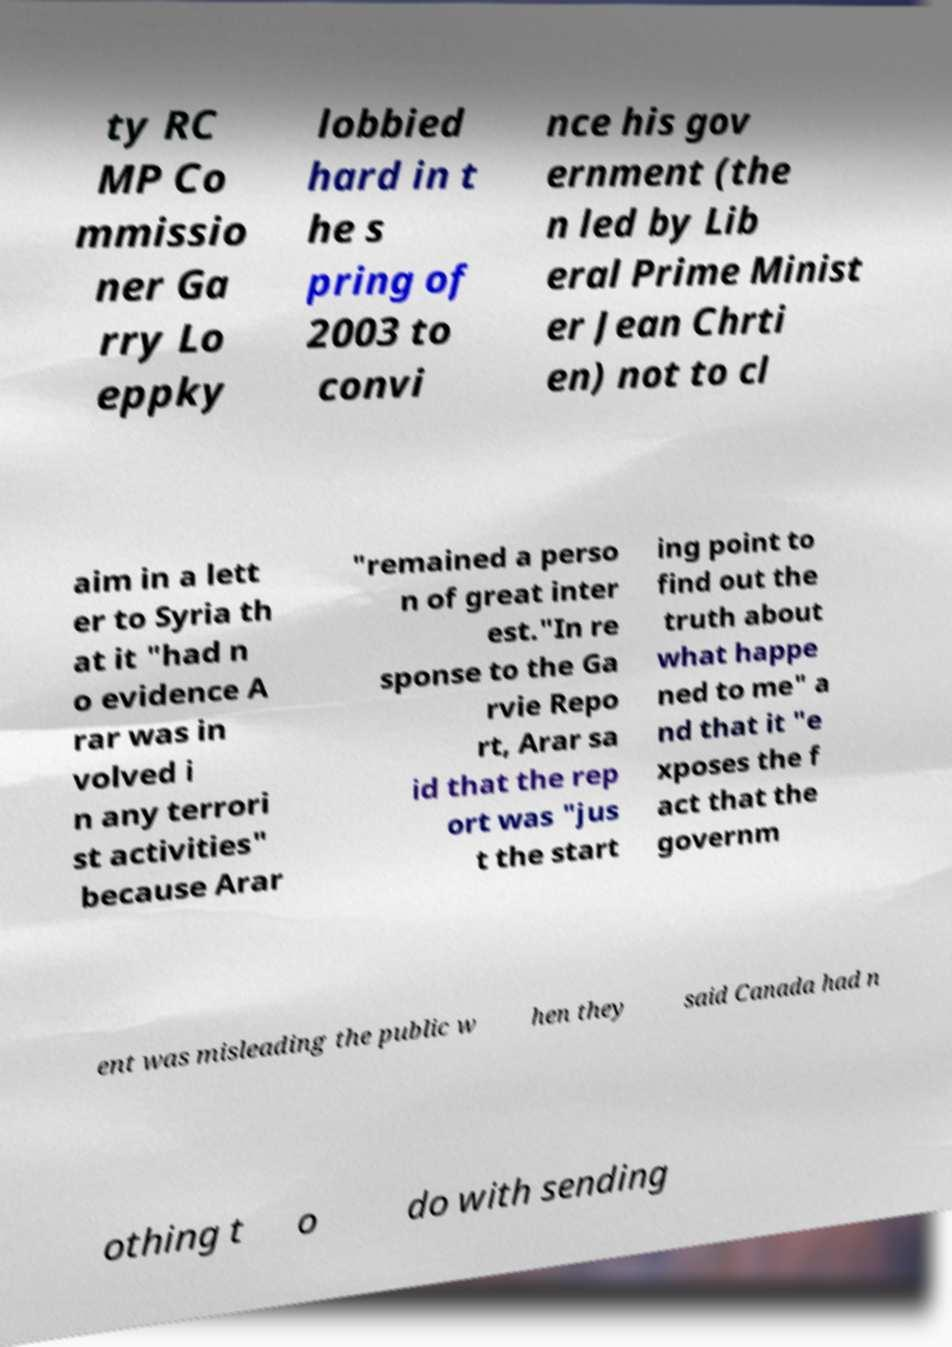What messages or text are displayed in this image? I need them in a readable, typed format. ty RC MP Co mmissio ner Ga rry Lo eppky lobbied hard in t he s pring of 2003 to convi nce his gov ernment (the n led by Lib eral Prime Minist er Jean Chrti en) not to cl aim in a lett er to Syria th at it "had n o evidence A rar was in volved i n any terrori st activities" because Arar "remained a perso n of great inter est."In re sponse to the Ga rvie Repo rt, Arar sa id that the rep ort was "jus t the start ing point to find out the truth about what happe ned to me" a nd that it "e xposes the f act that the governm ent was misleading the public w hen they said Canada had n othing t o do with sending 